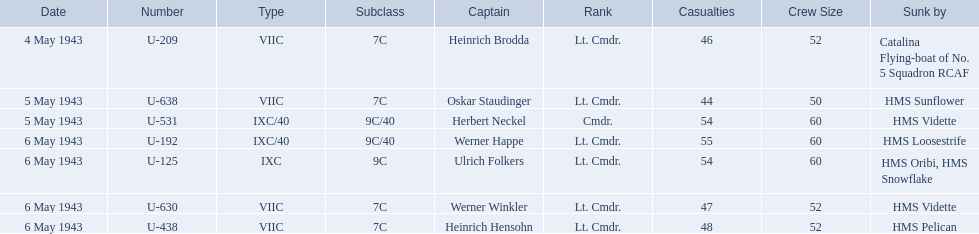What boats were lost on may 5? U-638, U-531. Who were the captains of those boats? Oskar Staudinger, Herbert Neckel. Which captain was not oskar staudinger? Herbert Neckel. 